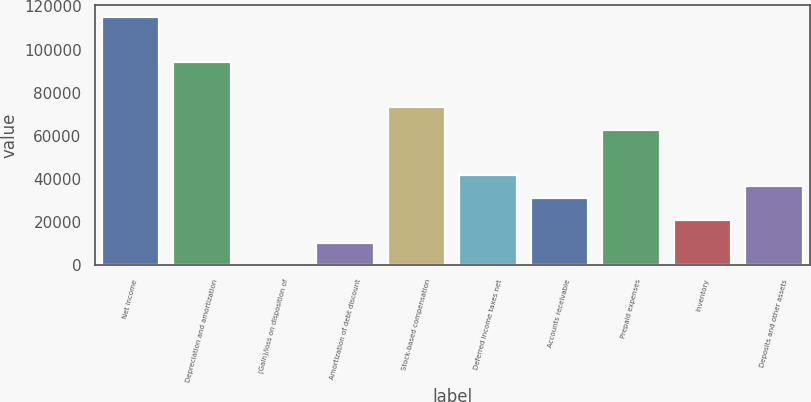Convert chart to OTSL. <chart><loc_0><loc_0><loc_500><loc_500><bar_chart><fcel>Net income<fcel>Depreciation and amortization<fcel>(Gain)/loss on disposition of<fcel>Amortization of debt discount<fcel>Stock-based compensation<fcel>Deferred income taxes net<fcel>Accounts receivable<fcel>Prepaid expenses<fcel>Inventory<fcel>Deposits and other assets<nl><fcel>115095<fcel>94171.2<fcel>15<fcel>10476.8<fcel>73247.6<fcel>41862.2<fcel>31400.4<fcel>62785.8<fcel>20938.6<fcel>36631.3<nl></chart> 